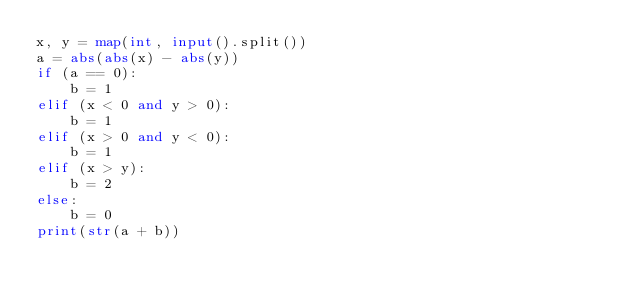<code> <loc_0><loc_0><loc_500><loc_500><_Python_>x, y = map(int, input().split())
a = abs(abs(x) - abs(y))
if (a == 0):
    b = 1
elif (x < 0 and y > 0):
    b = 1
elif (x > 0 and y < 0):
    b = 1
elif (x > y):
    b = 2
else:
    b = 0
print(str(a + b))</code> 